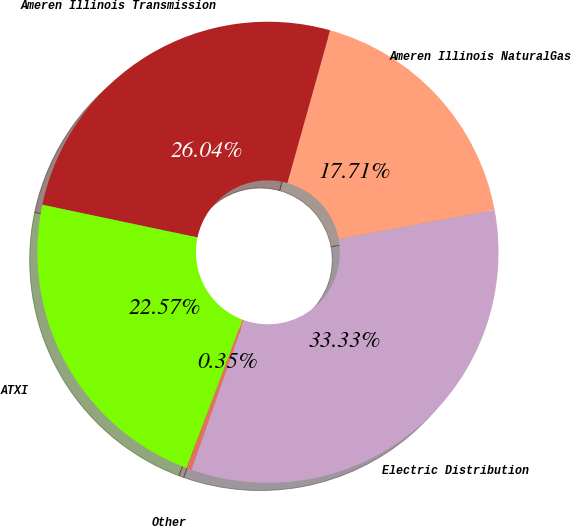Convert chart to OTSL. <chart><loc_0><loc_0><loc_500><loc_500><pie_chart><fcel>Electric Distribution<fcel>Ameren Illinois NaturalGas<fcel>Ameren Illinois Transmission<fcel>ATXI<fcel>Other<nl><fcel>33.33%<fcel>17.71%<fcel>26.04%<fcel>22.57%<fcel>0.35%<nl></chart> 